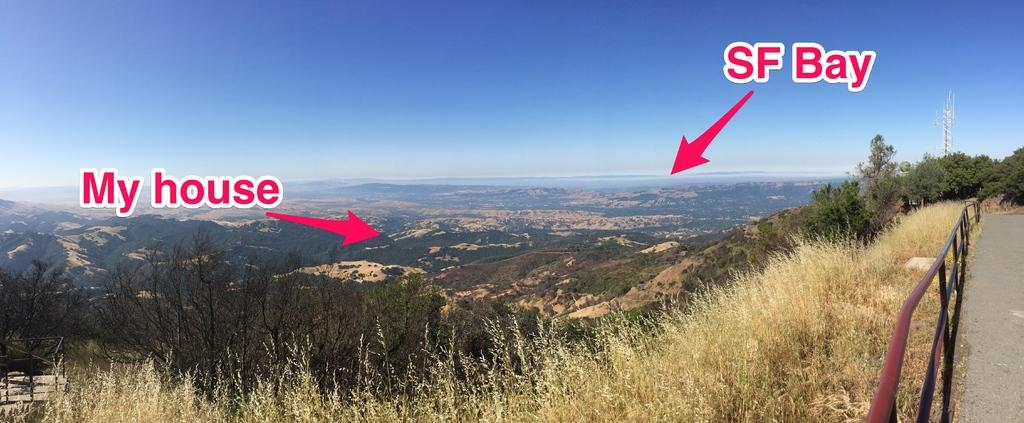<image>
Write a terse but informative summary of the picture. A scene overlooking a valley with arrows pointing out the location of a person's house in relation to the bay. 